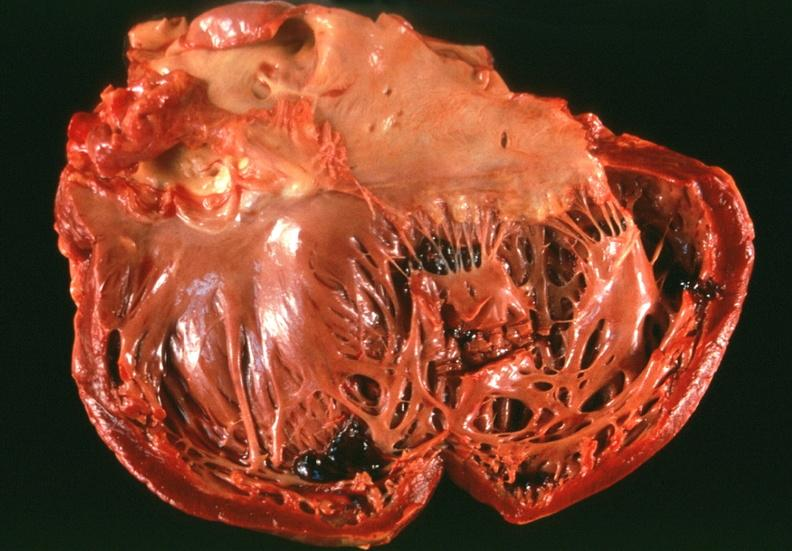does lateral view show congestive heart failure?
Answer the question using a single word or phrase. No 